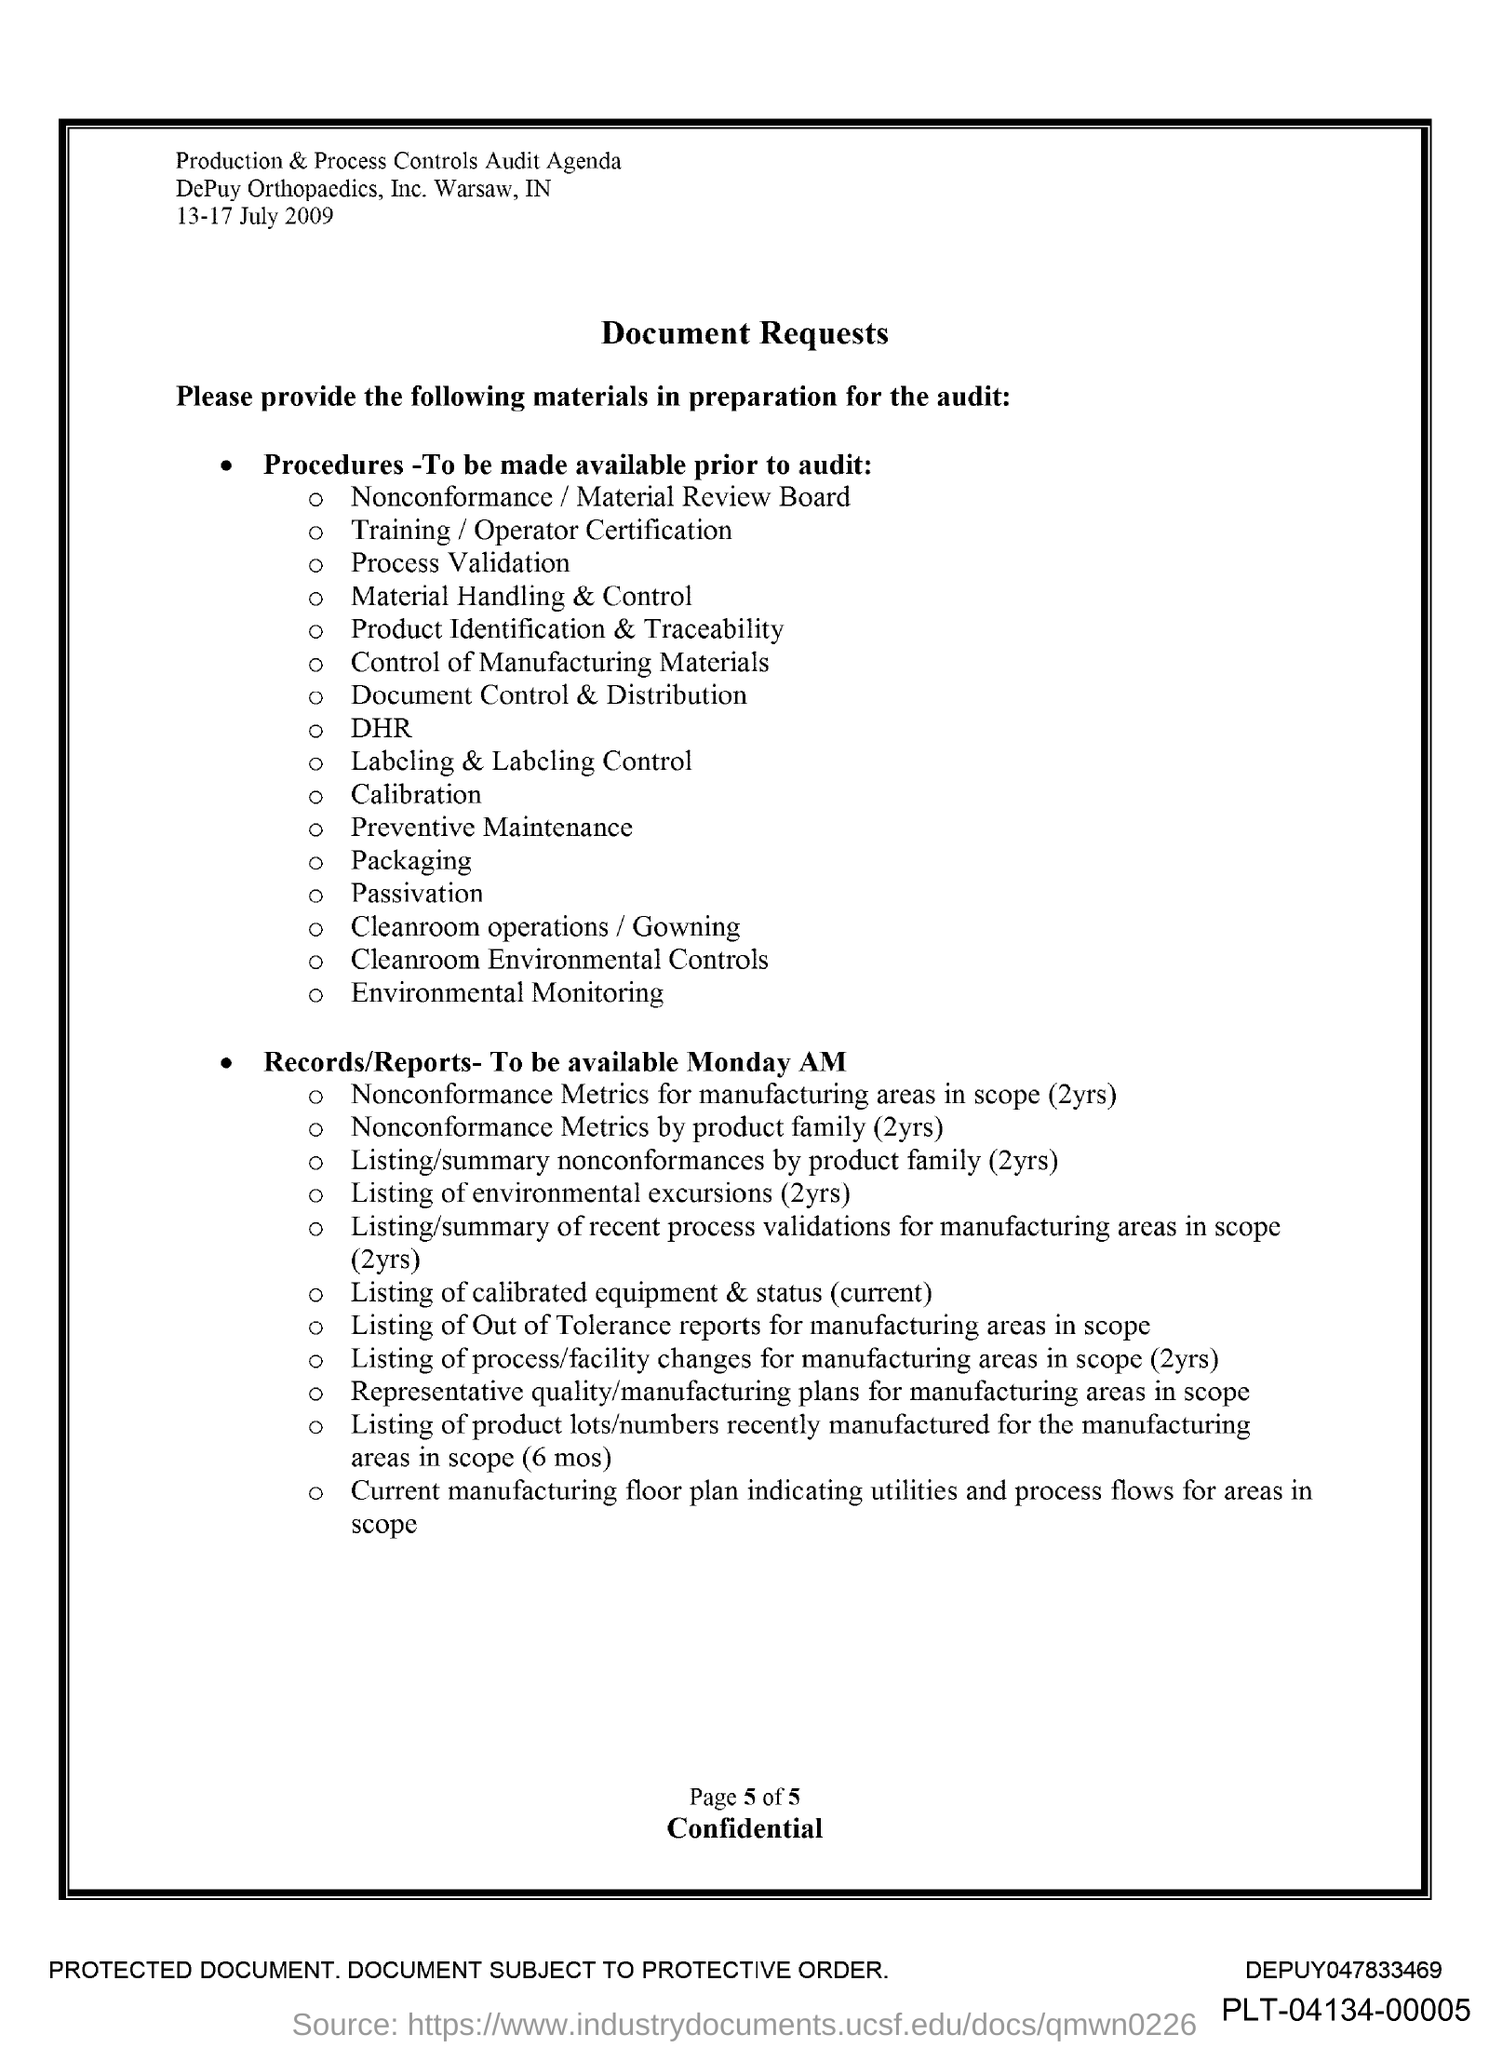What is the date mentioned in the document?
Ensure brevity in your answer.  13-17 July 2009. What is the title of the document?
Your answer should be very brief. Document Requests. 